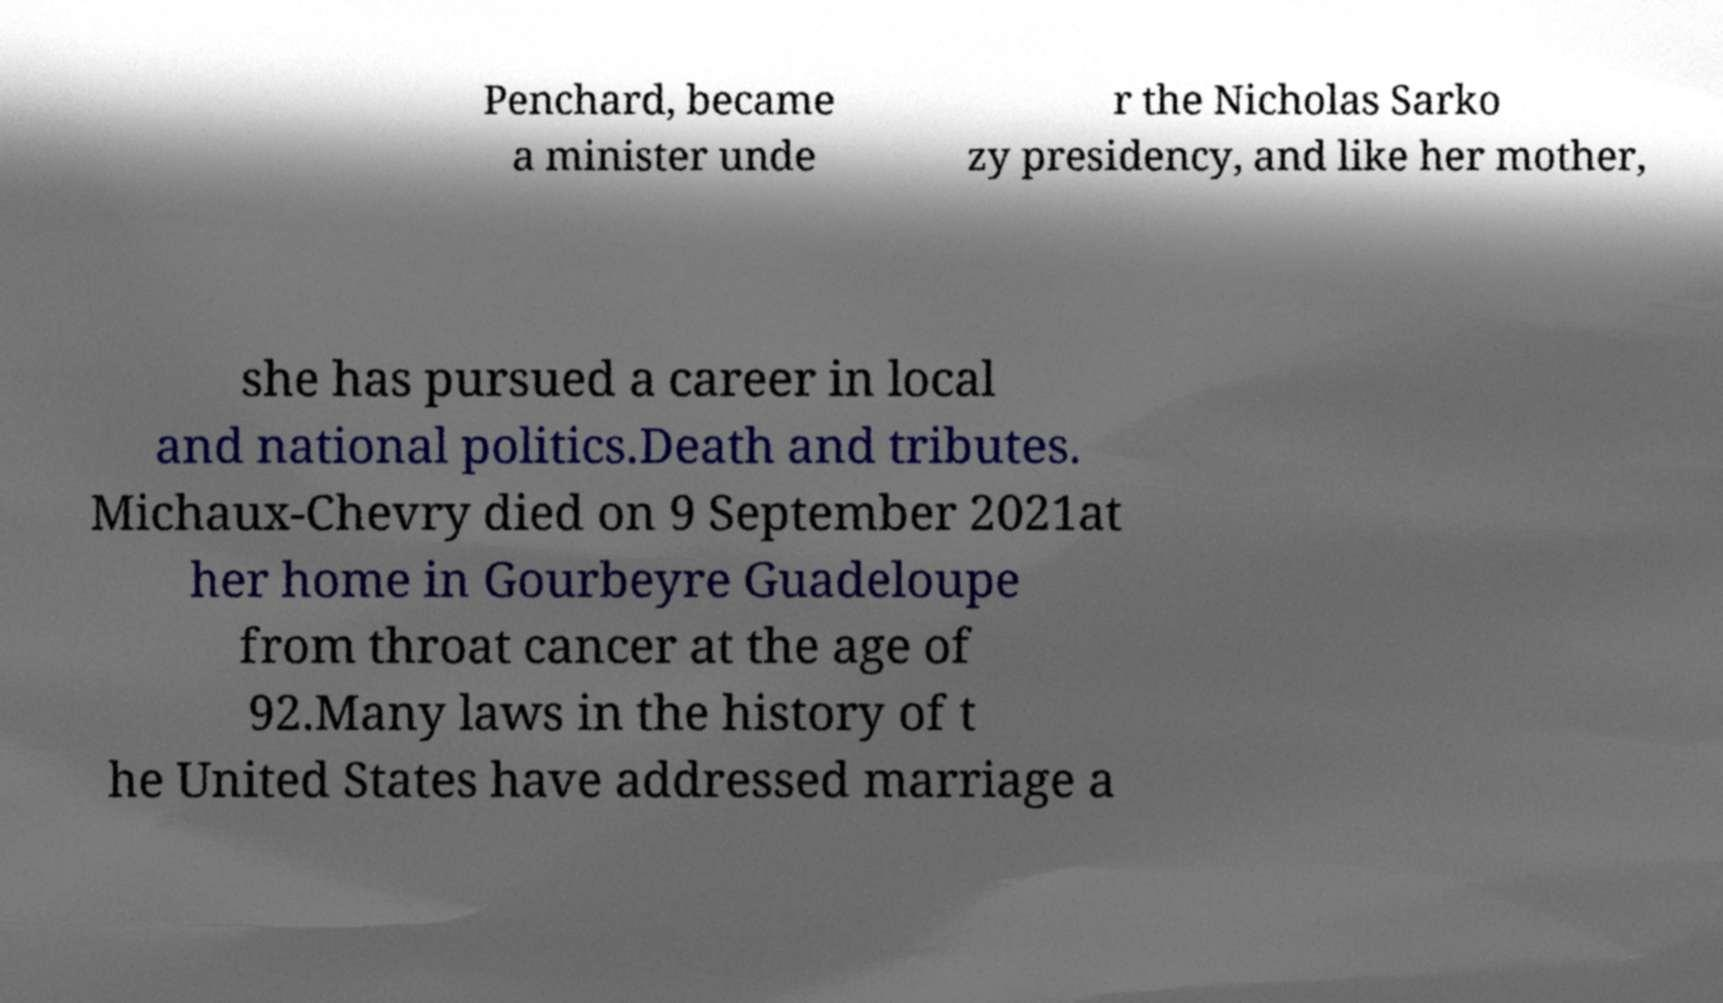Could you assist in decoding the text presented in this image and type it out clearly? Penchard, became a minister unde r the Nicholas Sarko zy presidency, and like her mother, she has pursued a career in local and national politics.Death and tributes. Michaux-Chevry died on 9 September 2021at her home in Gourbeyre Guadeloupe from throat cancer at the age of 92.Many laws in the history of t he United States have addressed marriage a 